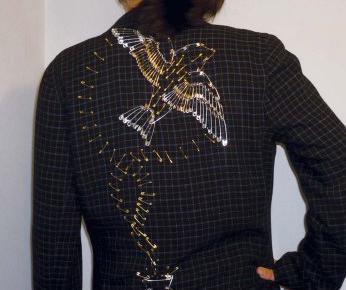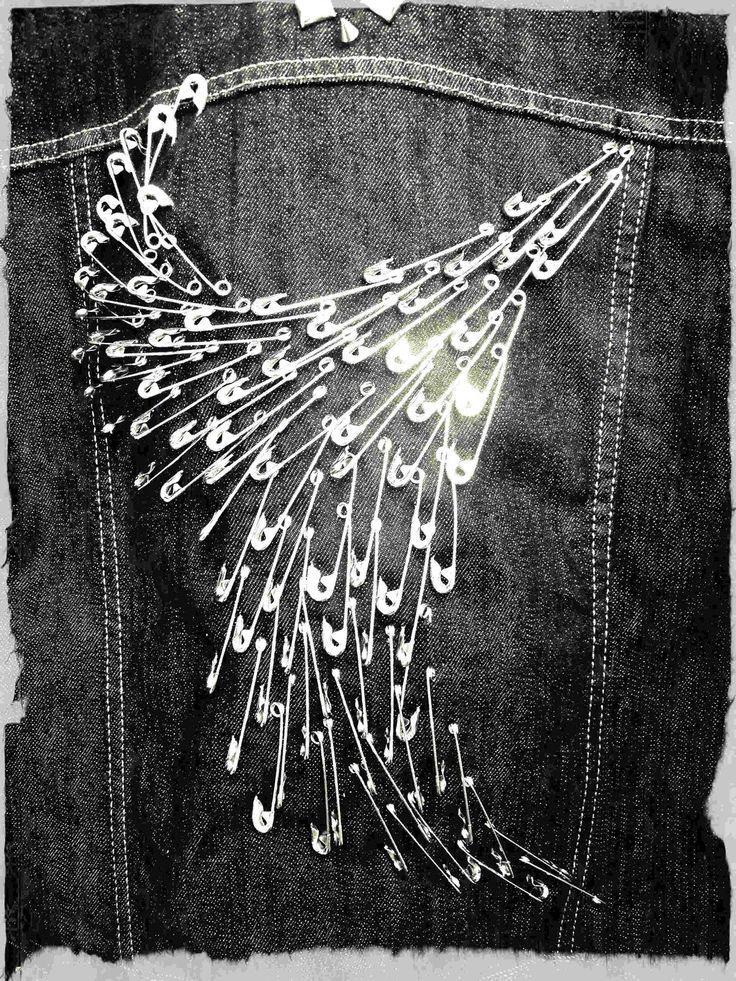The first image is the image on the left, the second image is the image on the right. For the images displayed, is the sentence "One image contains a person wearing a black jacket with a bird design on it." factually correct? Answer yes or no. Yes. The first image is the image on the left, the second image is the image on the right. Considering the images on both sides, is "A woman models the back of a jacket decorated with pins in the shape of a complete bird." valid? Answer yes or no. Yes. 